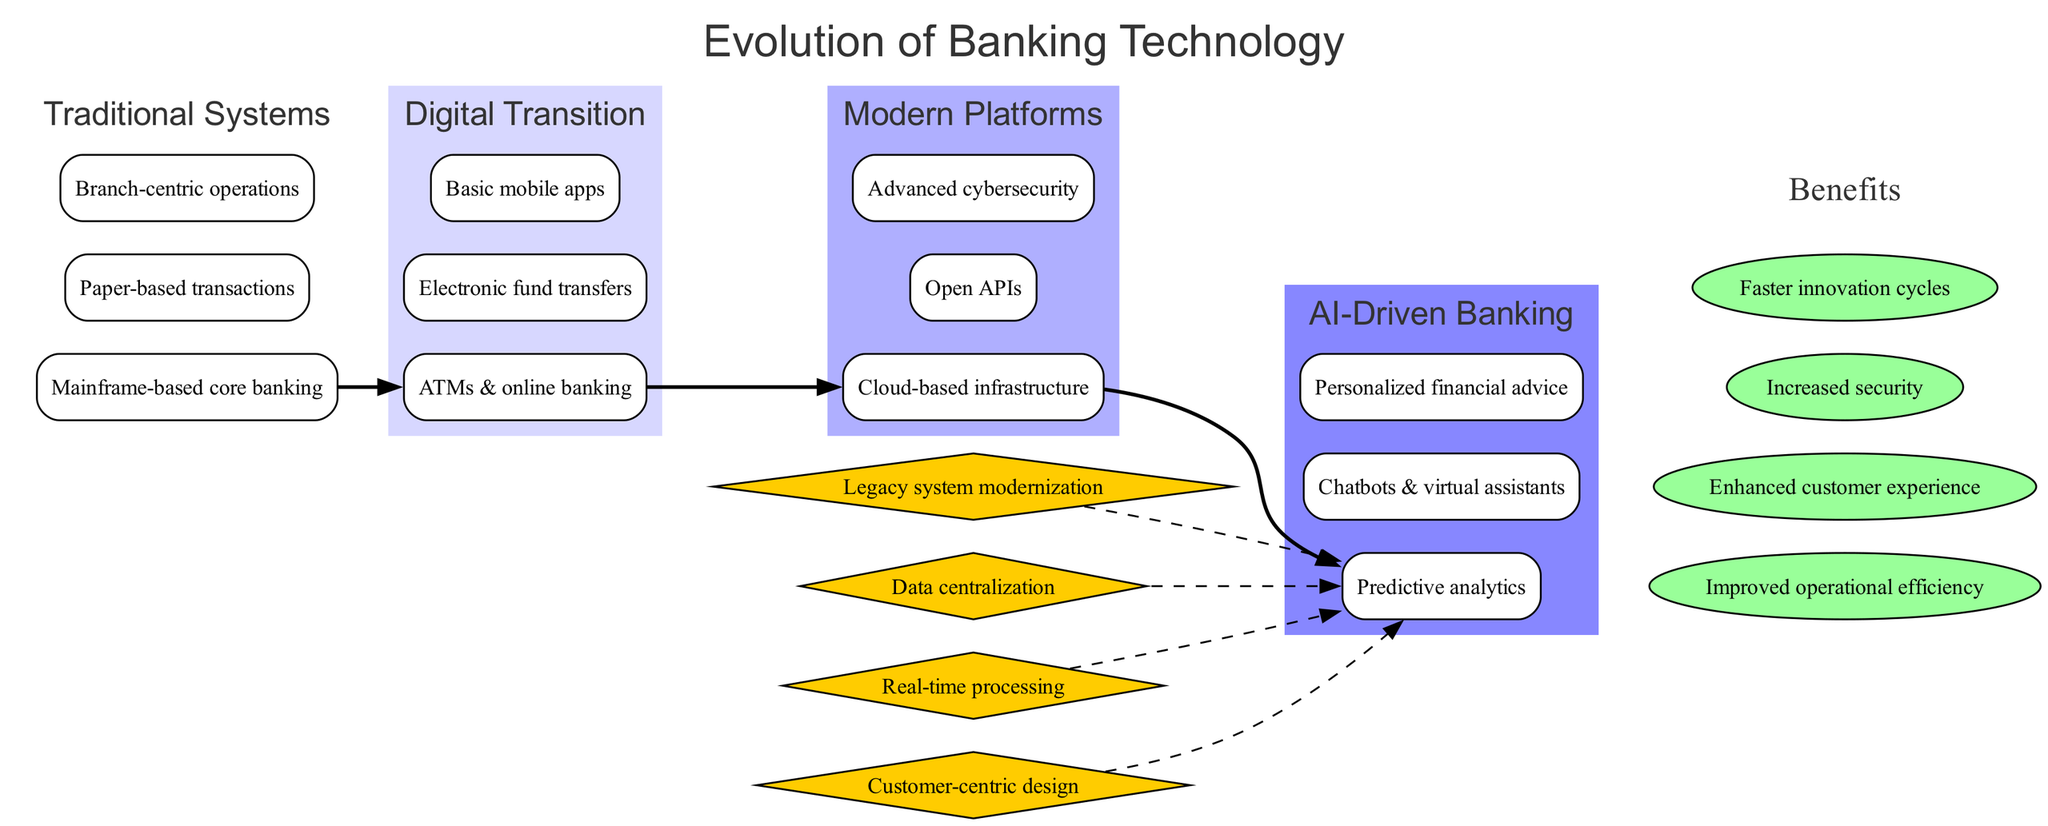What are the three main features of Traditional Systems? The diagram lists three features under the "Traditional Systems" stage: mainframe-based core banking, paper-based transactions, and branch-centric operations.
Answer: Mainframe-based core banking, paper-based transactions, branch-centric operations How many stages are depicted in the diagram? The diagram outlines four distinct stages: Traditional Systems, Digital Transition, Modern Platforms, and AI-Driven Banking. Therefore, there are four stages in total.
Answer: Four Which stage features Chatbots and virtual assistants? The feature "Chatbots & virtual assistants" is located under the "AI-Driven Banking" stage, making it the relevant stage that showcases this technology.
Answer: AI-Driven Banking What is the first transformation mentioned in the diagram? The diagram identifies "Legacy system modernization" as the first of the key transformations that connect the stages, hence it is the first one listed.
Answer: Legacy system modernization How do the transformations connect to the most recent stage? Each transformation is linked with a dashed edge to the last stage "AI-Driven Banking." This shows that these transformations lead up to this final development in banking technology.
Answer: They connect with dashed edges What benefit is associated with faster innovation cycles? The diagram lists "Faster innovation cycles" as one of the benefits, indicating that it contributes to the overall enhancement provided by the advancement in banking technology.
Answer: Faster innovation cycles Which features indicate the shift towards customer-centric design? The features "Predictive analytics," "Chatbots & virtual assistants," and "Personalized financial advice" under the "AI-Driven Banking" stage suggest a shift towards a more customer-centric approach in banking technology.
Answer: Predictive analytics, Chatbots & virtual assistants, Personalized financial advice What color represents the 'Digital Transition' stage in the diagram? The 'Digital Transition' stage is visually represented with a color that is progressively darker, showing the visual attribute assigned in the diagram, helping to distinguish it from other stages.
Answer: A shade of blue Which key transformation relates to Data Centralization? The transformation "Data centralization" is one of the key transformations listed, suggesting its importance in integrating the various banking technologies outlined in the diagram.
Answer: Data centralization 